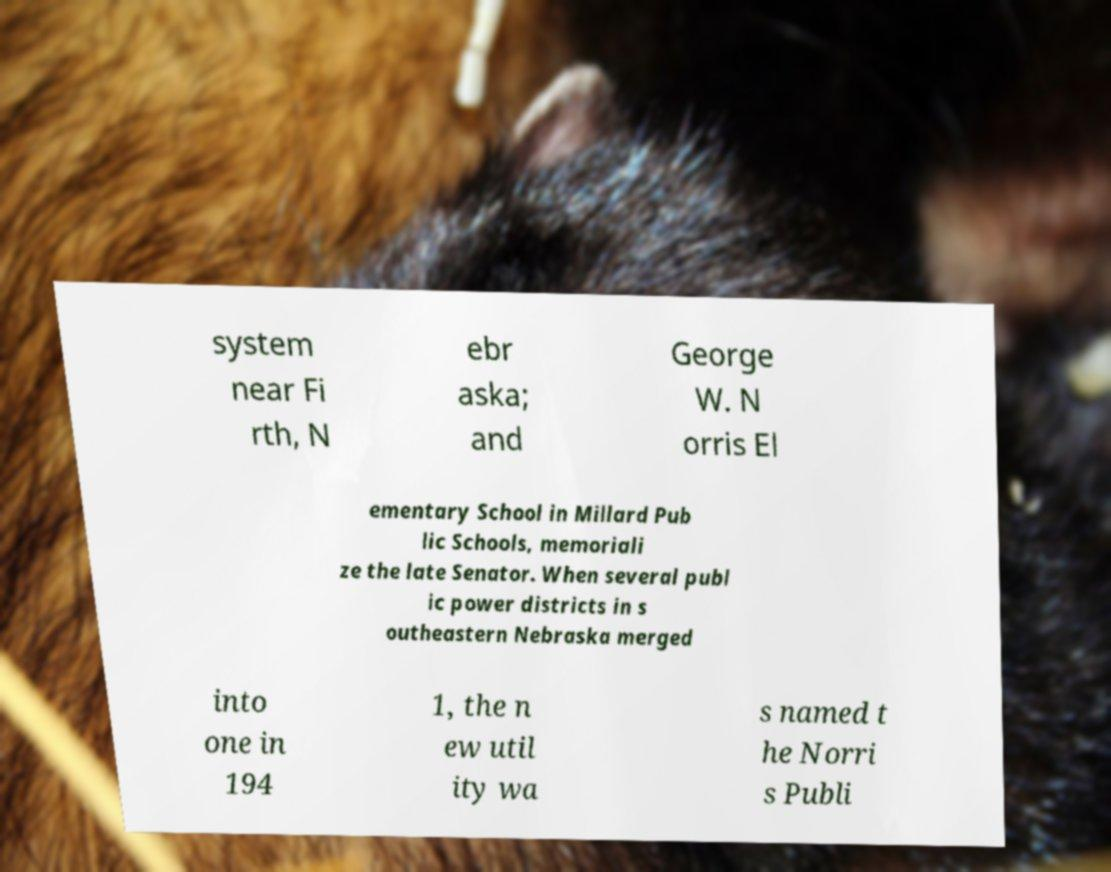There's text embedded in this image that I need extracted. Can you transcribe it verbatim? system near Fi rth, N ebr aska; and George W. N orris El ementary School in Millard Pub lic Schools, memoriali ze the late Senator. When several publ ic power districts in s outheastern Nebraska merged into one in 194 1, the n ew util ity wa s named t he Norri s Publi 